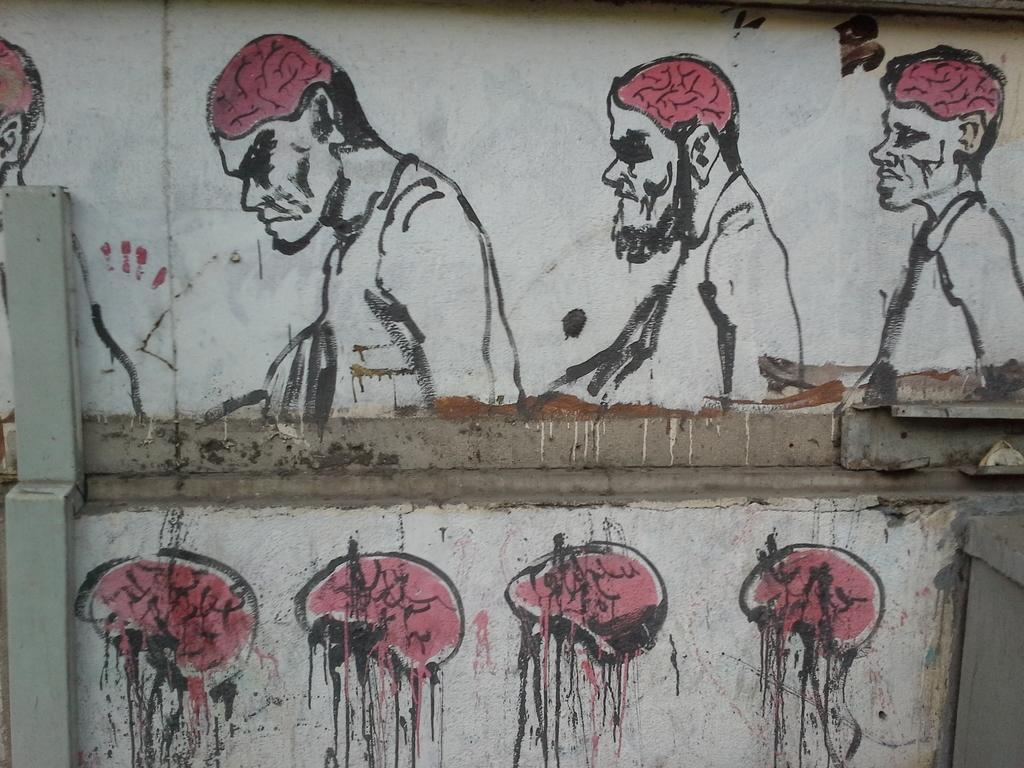What is the main feature in the center of the image? There is a wall in the center of the image. What is depicted on the wall? There is a drawing on the wall. What can be seen on the left side of the image? There is a pole on the left side of the image. What color is the blood on the tent in the image? There is no tent or blood present in the image. 